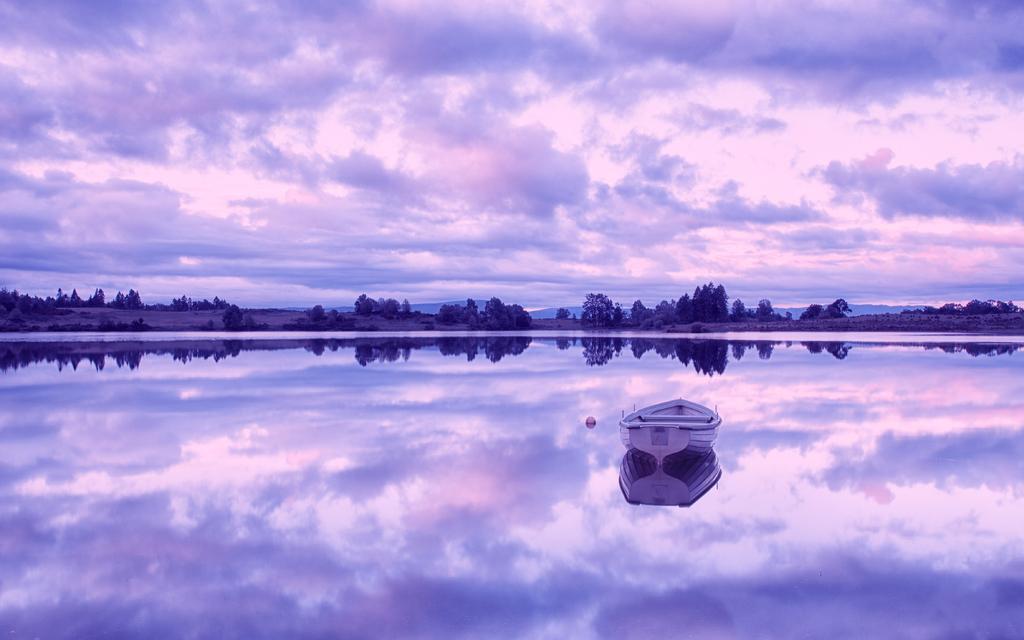Could you give a brief overview of what you see in this image? In this picture there is a boat on the water. In the background I can see the road, trees, plants, grass and mountains. At the top I can see the sky and clouds. At the bottom I can see the reflection of the sky, clouds, boat, trees and other objects in the water. 